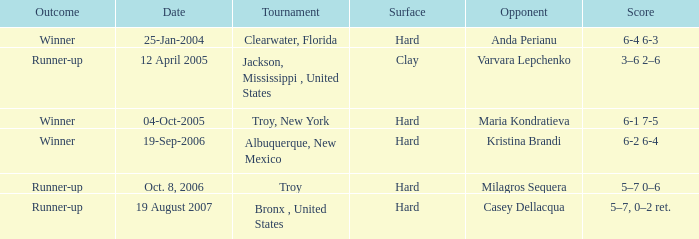What was the surface of the game that resulted in a final score of 6-1 7-5? Hard. Would you be able to parse every entry in this table? {'header': ['Outcome', 'Date', 'Tournament', 'Surface', 'Opponent', 'Score'], 'rows': [['Winner', '25-Jan-2004', 'Clearwater, Florida', 'Hard', 'Anda Perianu', '6-4 6-3'], ['Runner-up', '12 April 2005', 'Jackson, Mississippi , United States', 'Clay', 'Varvara Lepchenko', '3–6 2–6'], ['Winner', '04-Oct-2005', 'Troy, New York', 'Hard', 'Maria Kondratieva', '6-1 7-5'], ['Winner', '19-Sep-2006', 'Albuquerque, New Mexico', 'Hard', 'Kristina Brandi', '6-2 6-4'], ['Runner-up', 'Oct. 8, 2006', 'Troy', 'Hard', 'Milagros Sequera', '5–7 0–6'], ['Runner-up', '19 August 2007', 'Bronx , United States', 'Hard', 'Casey Dellacqua', '5–7, 0–2 ret.']]} 